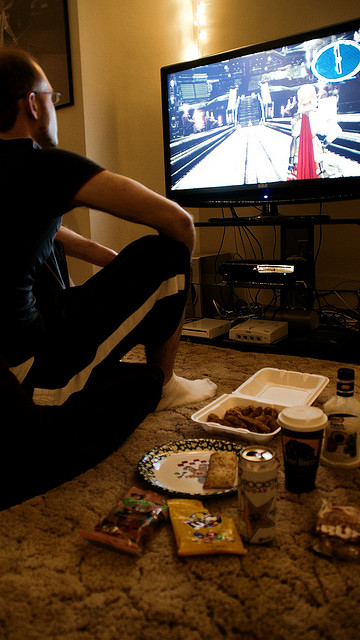Read and extract the text from this image. taxi 